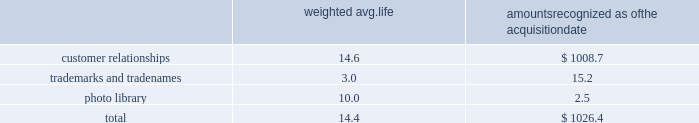Westrock company notes to consolidated financial statements fffd ( continued ) the table summarizes the weighted average life and the allocation to intangible assets recognized in the mps acquisition , excluding goodwill ( in millions ) : weighted avg .
Amounts recognized as the acquisition .
None of the intangibles has significant residual value .
We are amortizing the customer relationship intangibles over estimated useful lives ranging from 13 to 16 years based on a straight-line basis because the amortization pattern was not reliably determinable .
Star pizza acquisition on march 13 , 2017 , we completed the star pizza acquisition .
The transaction provided us with a leadership position in the fast growing small-run pizza box market and increases our vertical integration .
The purchase price was $ 34.6 million , net of a $ 0.7 million working capital settlement .
We have fully integrated the approximately 22000 tons of containerboard used by star pizza annually .
We have included the financial results of the acquired assets since the date of the acquisition in our corrugated packaging segment .
The purchase price allocation for the acquisition primarily included $ 24.8 million of customer relationship intangible assets and $ 2.2 million of goodwill .
We are amortizing the customer relationship intangibles over 10 years based on a straight-line basis because the amortization pattern was not reliably determinable .
The fair value assigned to goodwill is primarily attributable to buyer-specific synergies expected to arise after the acquisition ( e.g. , enhanced reach of the combined organization and other synergies ) , and the assembled work force .
The goodwill and intangibles are amortizable for income tax purposes .
Packaging acquisition on january 19 , 2016 , we completed the packaging acquisition .
The entities acquired provide value-added folding carton and litho-laminated display packaging solutions .
The purchase price was $ 94.1 million , net of cash received of $ 1.7 million , a working capital settlement and a $ 3.5 million escrow receipt in the first quarter of fiscal 2017 .
The transaction is subject to an election under section 338 ( h ) ( 10 ) of the code that increases the u.s .
Tax basis in the acquired u.s .
Entities .
We believe the transaction has provided us with attractive and complementary customers , markets and facilities .
We have included the financial results of the acquired entities since the date of the acquisition in our consumer packaging segment .
The purchase price allocation for the acquisition primarily included $ 55.0 million of property , plant and equipment , $ 10.5 million of customer relationship intangible assets , $ 9.3 million of goodwill and $ 25.8 million of liabilities , including $ 1.3 million of debt .
We are amortizing the customer relationship intangibles over estimated useful lives ranging from 9 to 15 years based on a straight-line basis because the amortization pattern was not reliably determinable .
The fair value assigned to goodwill is primarily attributable to buyer-specific synergies expected to arise after the acquisition ( e.g. , enhanced reach of the combined organization and other synergies ) , and the assembled work force .
The goodwill and intangibles of the u.s .
Entities are amortizable for income tax purposes .
Sp fiber on october 1 , 2015 , we completed the sp fiber acquisition in a stock purchase .
The transaction included the acquisition of mills located in dublin , ga and newberg , or , which produce lightweight recycled containerboard and kraft and bag paper .
The newberg mill also produced newsprint .
As part of the transaction , we also acquired sp fiber's 48% ( 48 % ) interest in gps .
Gps is a joint venture providing steam to the dublin mill and electricity to georgia power .
The purchase price was $ 278.8 million , net of cash received of $ 9.2 million and a working capital .
How much of the cost of the acquisition was not goodwill and intangible assets? 
Rationale: to find the amount of money that was not included in the intangible assets and goodwill . we must take the purchase price and subtract the goodwill and intangible assets .
Computations: (34.6 - 24.8)
Answer: 9.8. 